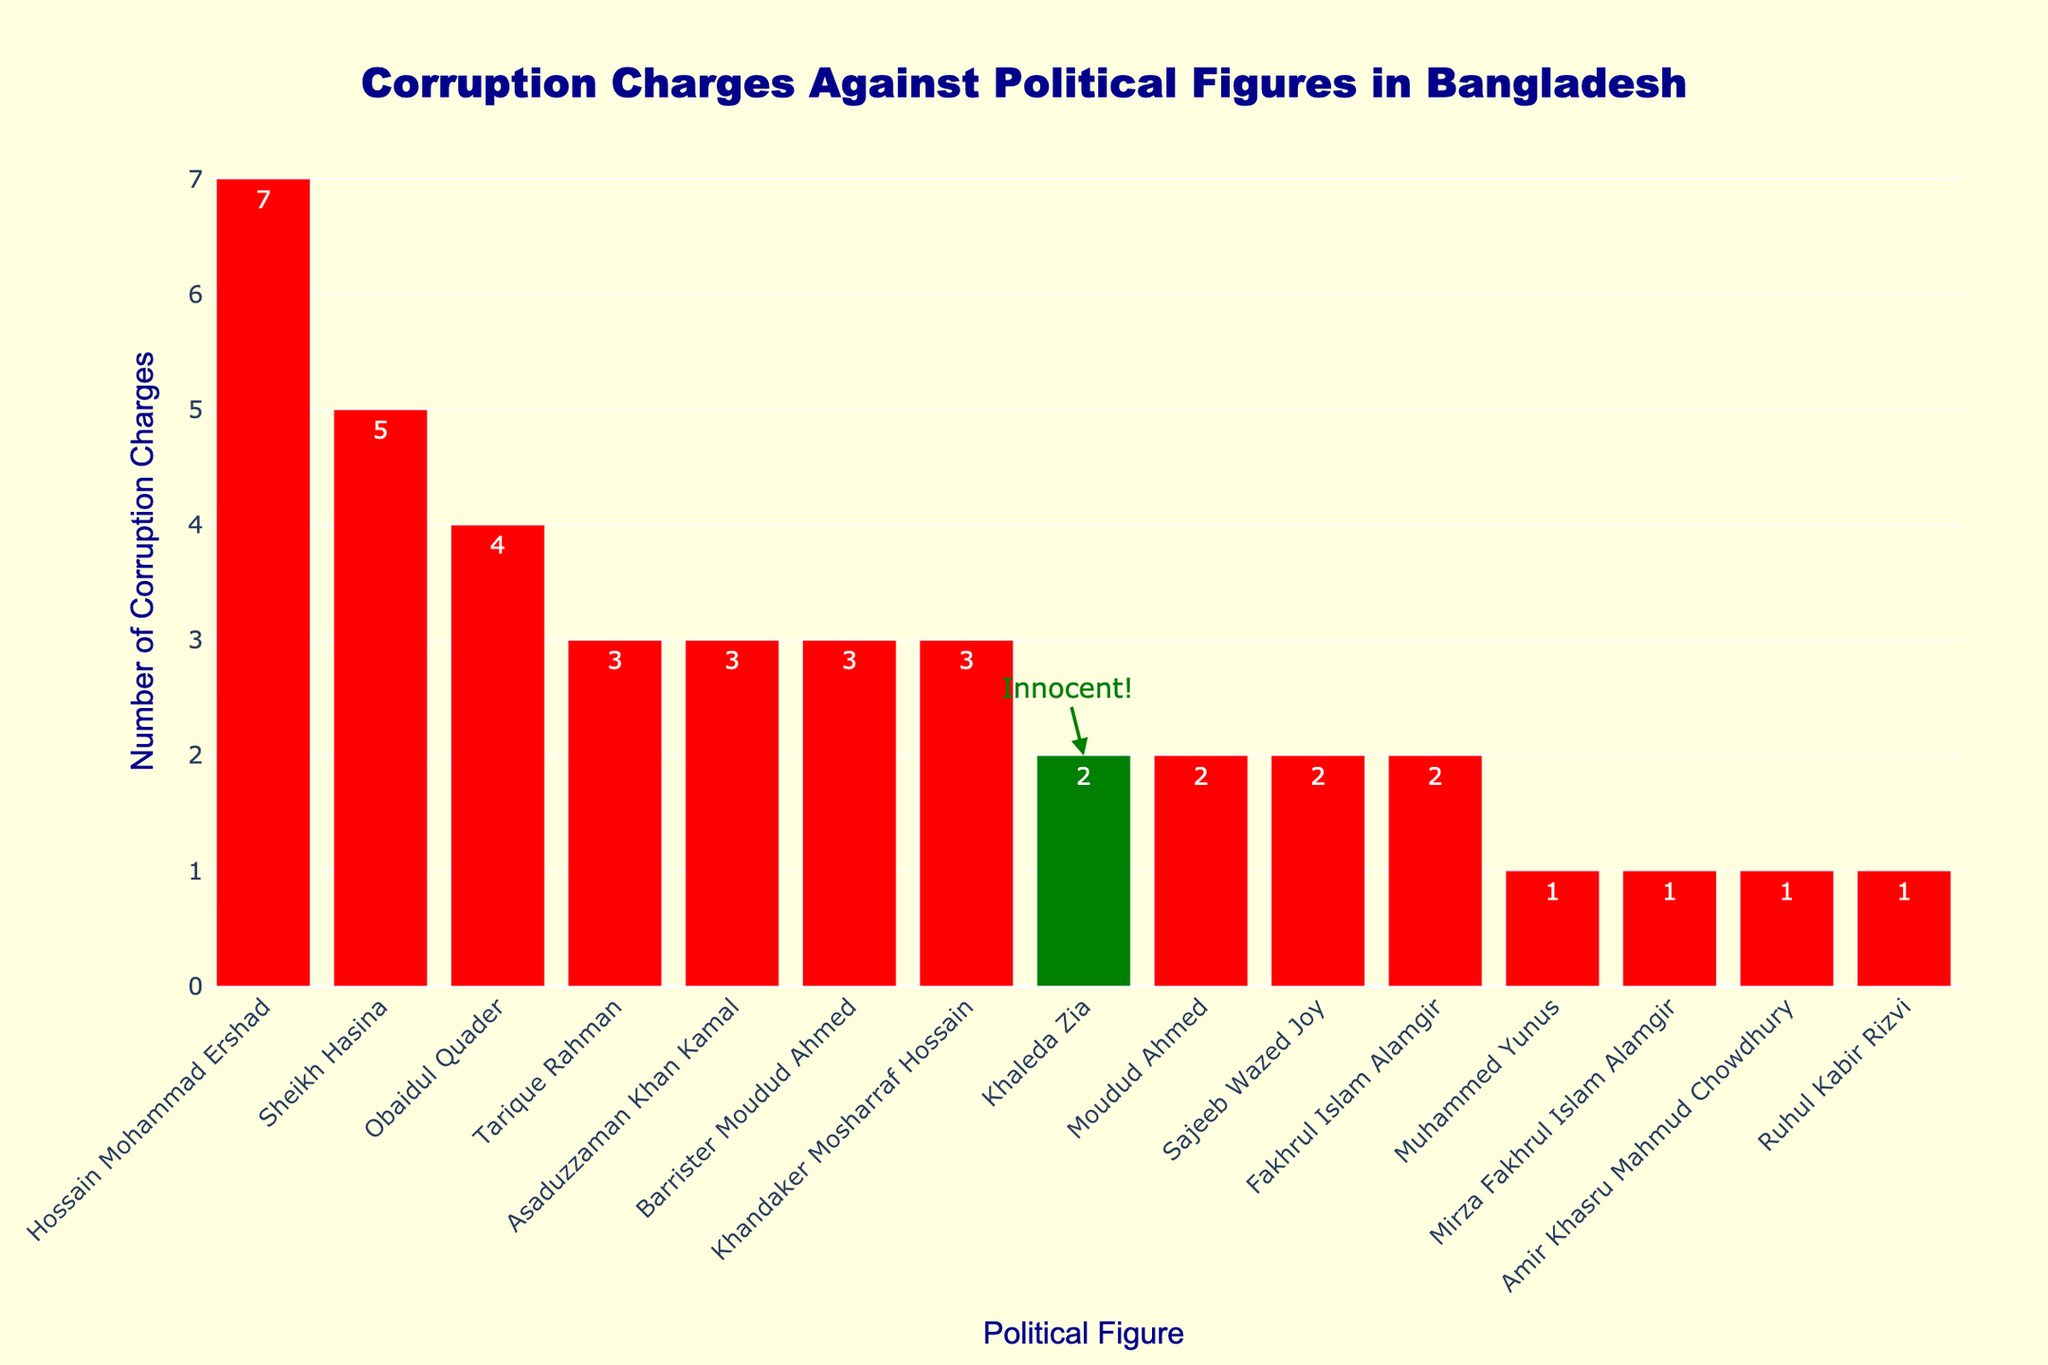1. Which political figure has the highest number of corruption charges? The figure shows that Hossain Mohammad Ershad has bars with the highest height among all the political figures indicating the highest number of corruption charges.
Answer: Hossain Mohammad Ershad 2. How many more corruption charges does Sheikh Hasina have compared to Khaleda Zia? Sheikh Hasina has 5 corruption charges, and Khaleda Zia has 2. The difference is 5 - 2 = 3.
Answer: 3 3. What is the total number of corruption charges against Khaleda Zia and Tarique Rahman combined? Khaleda Zia has 2 corruption charges, and Tarique Rahman has 3. Their combined total is 2 + 3.
Answer: 5 4. How many political figures have fewer than 3 corruption charges? The bars for Khaleda Zia, Muhammed Yunus, Mirza Fakhrul Islam Alamgir, Amir Khasru Mahmud Chowdhury, Ruhul Kabir Rizvi, and some other figures show less than 3 charges. Count these figures.
Answer: 7 5. Which political figure has the second-highest number of corruption charges? After Hossain Mohammad Ershad, the next tallest bar corresponds to Sheikh Hasina, indicating she has the second-highest number of corruption charges.
Answer: Sheikh Hasina 6. What is the sum of corruption charges for all political figures listed? Sum all the corruption charges presented in the figure: 1 + 2 + 3 + 4 + 2 + 3 + 5 + 1 + 2 + 7 + 1 + 1 + 2 + 3.
Answer: 37 7. Are there any political figures with exactly 3 corruption charges? If yes, name them. The bars with a height of 3 indicate those with exactly 3 corruption charges. These are Tarique Rahman, Asaduzzaman Khan Kamal, and Barrister Moudud Ahmed.
Answer: Tarique Rahman, Asaduzzaman Khan Kamal, Barrister Moudud Ahmed 8. Is the number of corruption charges against Khaleda Zia higher, equal, or lower compared to Obaidul Quader? Khaleda Zia has fewer corruption charges (2) compared to Obaidul Quader (4).
Answer: Lower 9. How many political figures have more corruption charges than Khaleda Zia? Hossain Mohammad Ershad, Sheikh Hasina, Tarique Rahman, Obaidul Quader, Asaduzzaman Khan Kamal, and Barrister Moudud Ahmed all have more corruption charges than Khaleda Zia. Count these figures.
Answer: 6 